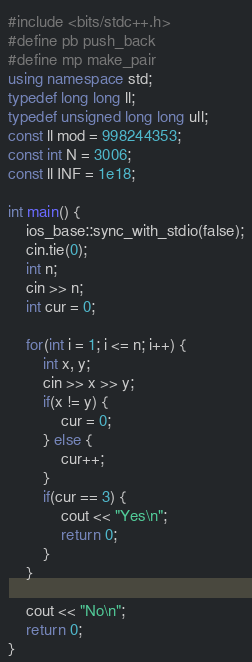Convert code to text. <code><loc_0><loc_0><loc_500><loc_500><_C++_>#include <bits/stdc++.h>
#define pb push_back
#define mp make_pair
using namespace std;
typedef long long ll;
typedef unsigned long long ull;
const ll mod = 998244353;
const int N = 3006;
const ll INF = 1e18;

int main() {
    ios_base::sync_with_stdio(false);
    cin.tie(0);
    int n;
    cin >> n;
    int cur = 0;

    for(int i = 1; i <= n; i++) {
        int x, y;
        cin >> x >> y;
        if(x != y) {
            cur = 0;
        } else {
            cur++;
        }
        if(cur == 3) {
            cout << "Yes\n";
            return 0;
        }
    }
    
    cout << "No\n";
    return 0;
}</code> 